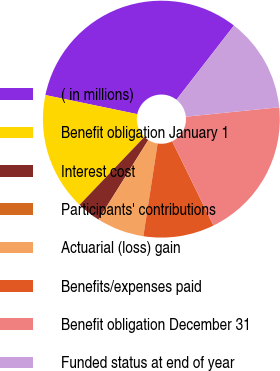<chart> <loc_0><loc_0><loc_500><loc_500><pie_chart><fcel>( in millions)<fcel>Benefit obligation January 1<fcel>Interest cost<fcel>Participants' contributions<fcel>Actuarial (loss) gain<fcel>Benefits/expenses paid<fcel>Benefit obligation December 31<fcel>Funded status at end of year<nl><fcel>32.24%<fcel>16.13%<fcel>3.23%<fcel>0.01%<fcel>6.46%<fcel>9.68%<fcel>19.35%<fcel>12.9%<nl></chart> 